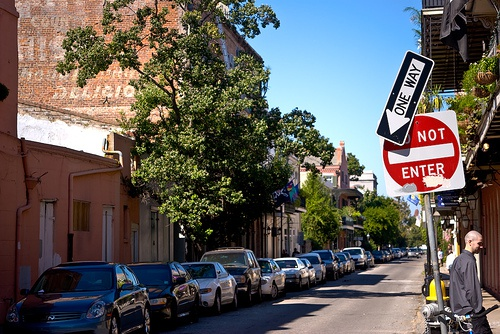Describe the objects in this image and their specific colors. I can see car in maroon, black, navy, gray, and darkblue tones, car in maroon, black, navy, and gray tones, people in maroon, gray, black, and lightpink tones, car in maroon, black, gray, and navy tones, and car in maroon, black, gray, and navy tones in this image. 